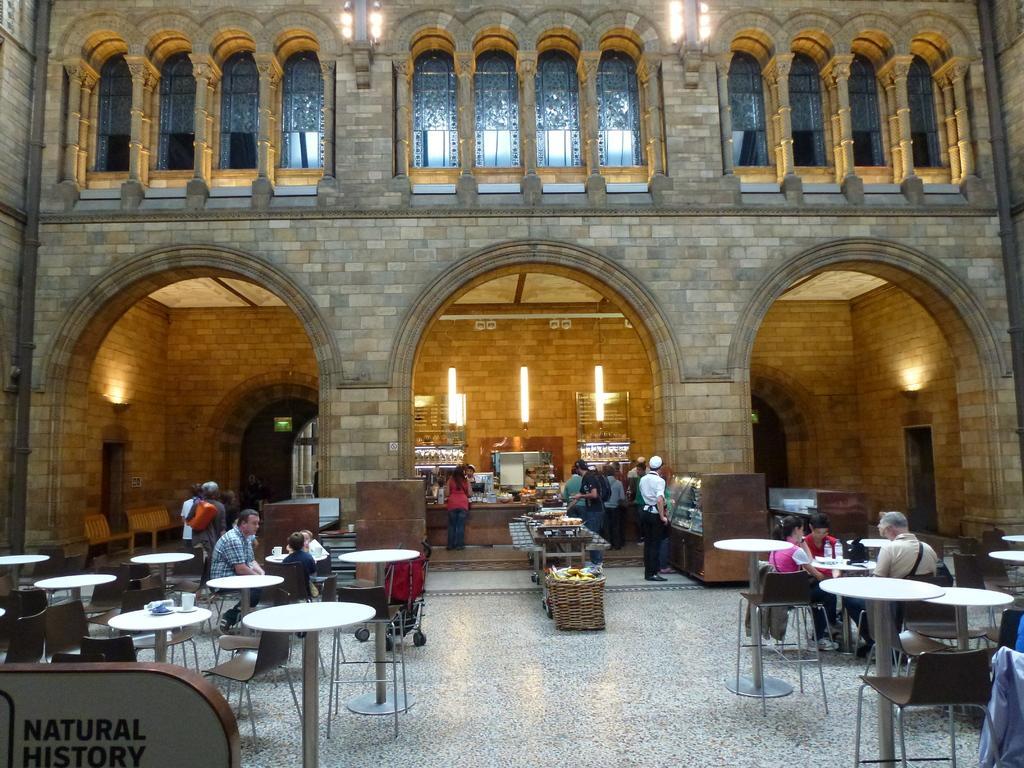Could you give a brief overview of what you see in this image? In this picture there are group of people those who are sitting on the chairs around tables and there is a place where all the food stock is kept at the center of the image, it seems to be a restaurant. 